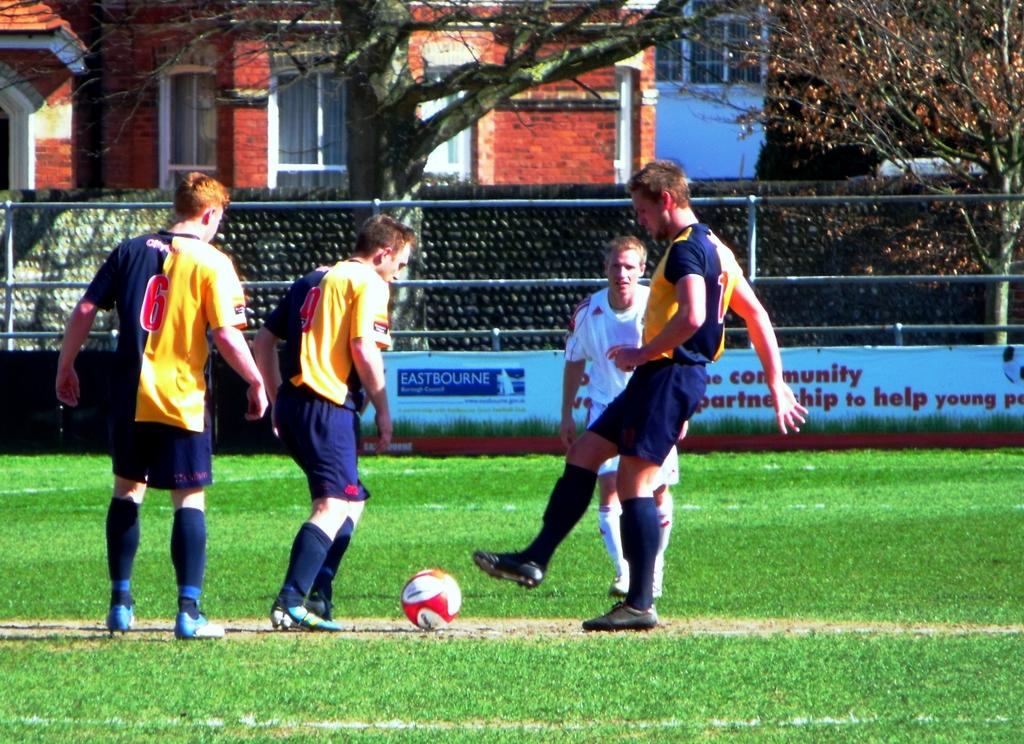<image>
Relay a brief, clear account of the picture shown. Soccer players are on a field, in front of an advertisement for Eastbourne. 